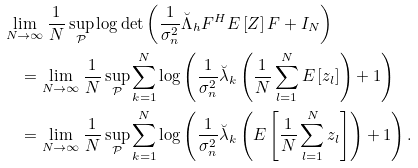<formula> <loc_0><loc_0><loc_500><loc_500>& \lim _ { N \rightarrow \infty } \frac { 1 } { N } \sup _ { \mathcal { P } } \log \det \left ( \frac { 1 } { \sigma _ { n } ^ { 2 } } \breve { \Lambda } _ { h } F ^ { H } E \left [ Z \right ] F + I _ { N } \right ) \\ & \quad = \lim _ { N \rightarrow \infty } \frac { 1 } { N } \sup _ { \mathcal { P } } \sum _ { k = 1 } ^ { N } \log \left ( \frac { 1 } { \sigma _ { n } ^ { 2 } } \breve { \lambda } _ { k } \left ( \frac { 1 } { N } \sum _ { l = 1 } ^ { N } E \left [ z _ { l } \right ] \right ) + 1 \right ) \\ & \quad = \lim _ { N \rightarrow \infty } \frac { 1 } { N } \sup _ { \mathcal { P } } \sum _ { k = 1 } ^ { N } \log \left ( \frac { 1 } { \sigma _ { n } ^ { 2 } } \breve { \lambda } _ { k } \left ( E \left [ \frac { 1 } { N } \sum _ { l = 1 } ^ { N } z _ { l } \right ] \right ) + 1 \right ) .</formula> 